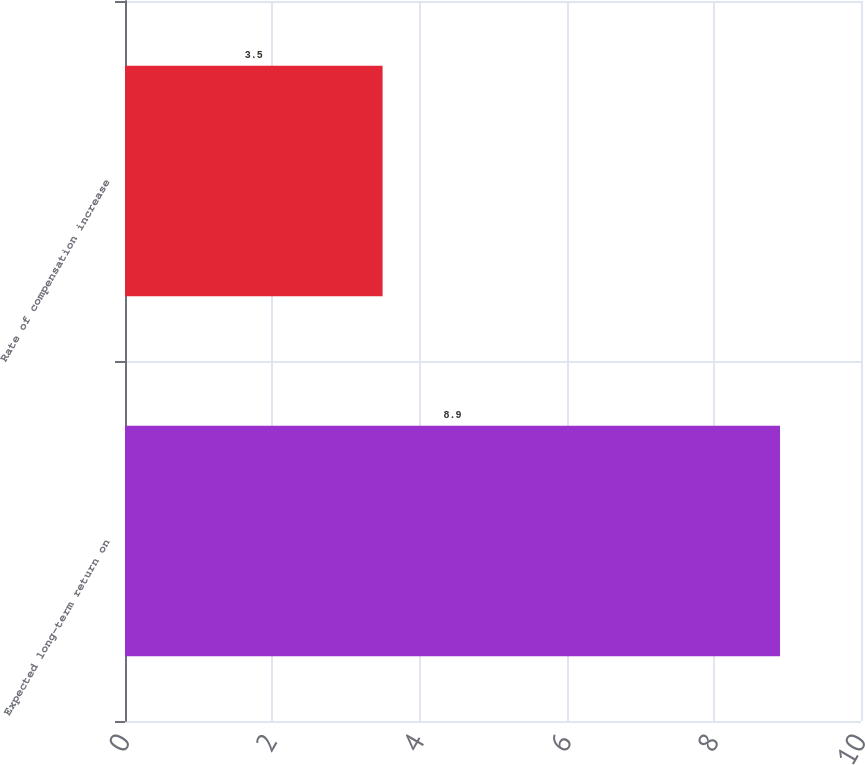Convert chart to OTSL. <chart><loc_0><loc_0><loc_500><loc_500><bar_chart><fcel>Expected long-term return on<fcel>Rate of compensation increase<nl><fcel>8.9<fcel>3.5<nl></chart> 